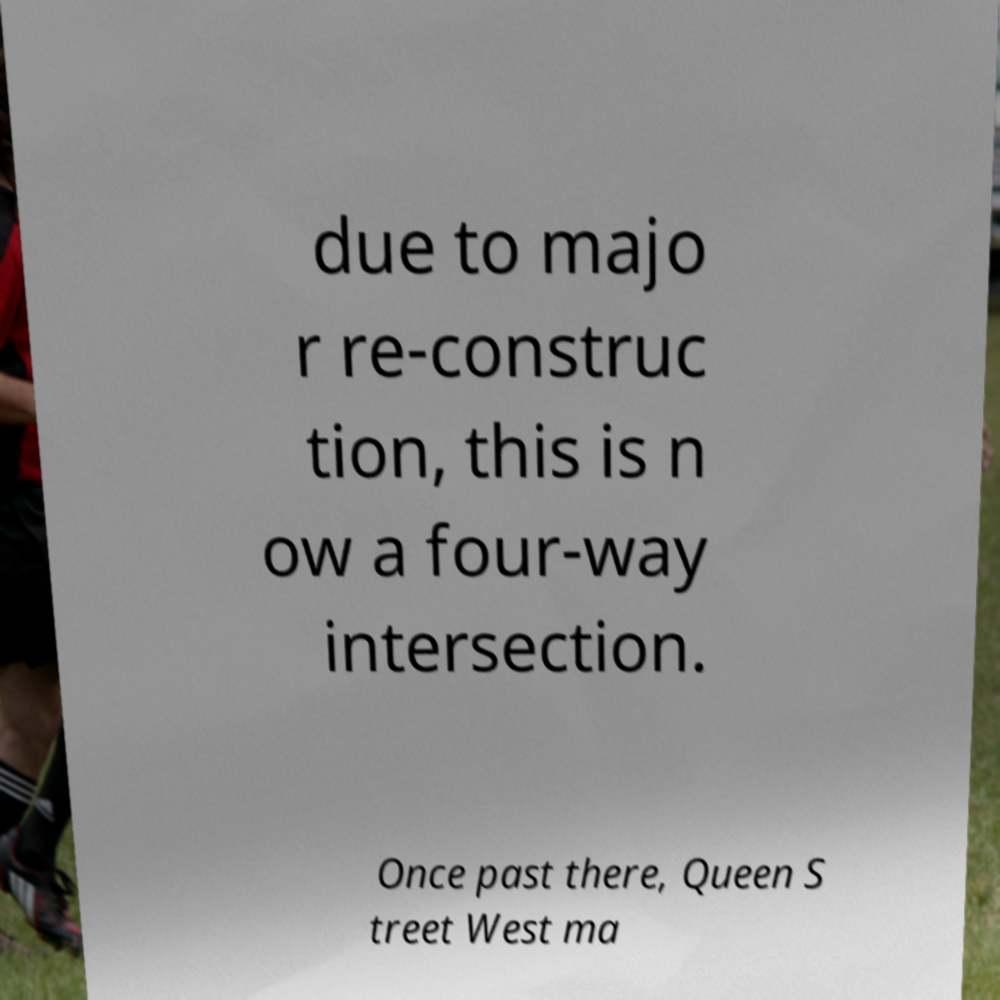I need the written content from this picture converted into text. Can you do that? due to majo r re-construc tion, this is n ow a four-way intersection. Once past there, Queen S treet West ma 